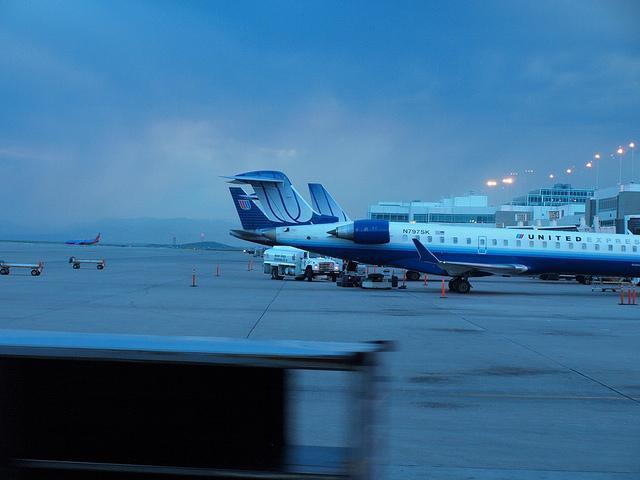How many people are wearing a green hat?
Give a very brief answer. 0. 